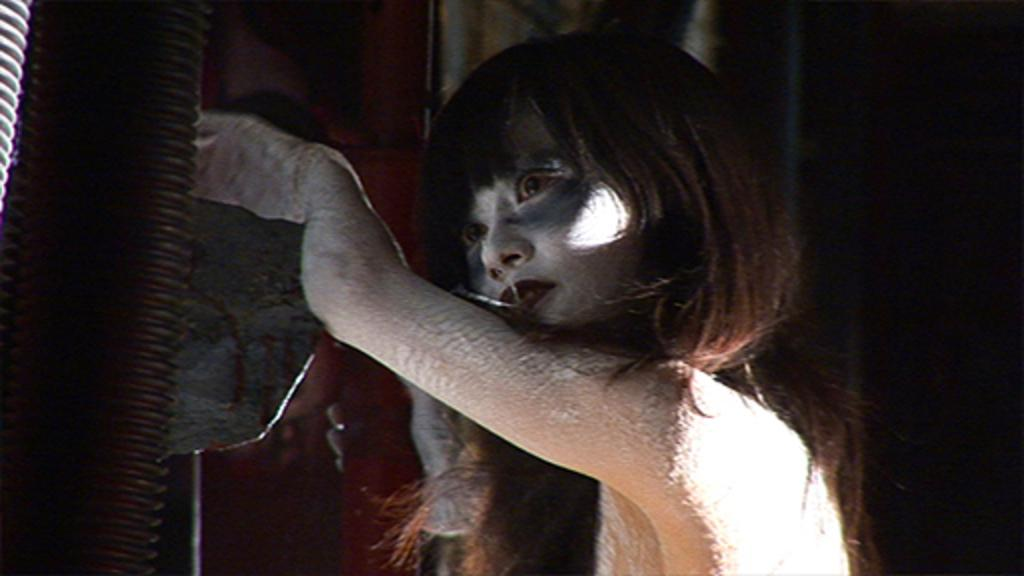Who is the main subject in the image? There is a girl in the image. What is the girl doing in the image? The girl is putting her hand on something. What is the color of the background in the image? The background of the image is black in color. What type of mine can be seen in the background of the image? There is no mine present in the image; the background is black in color. 